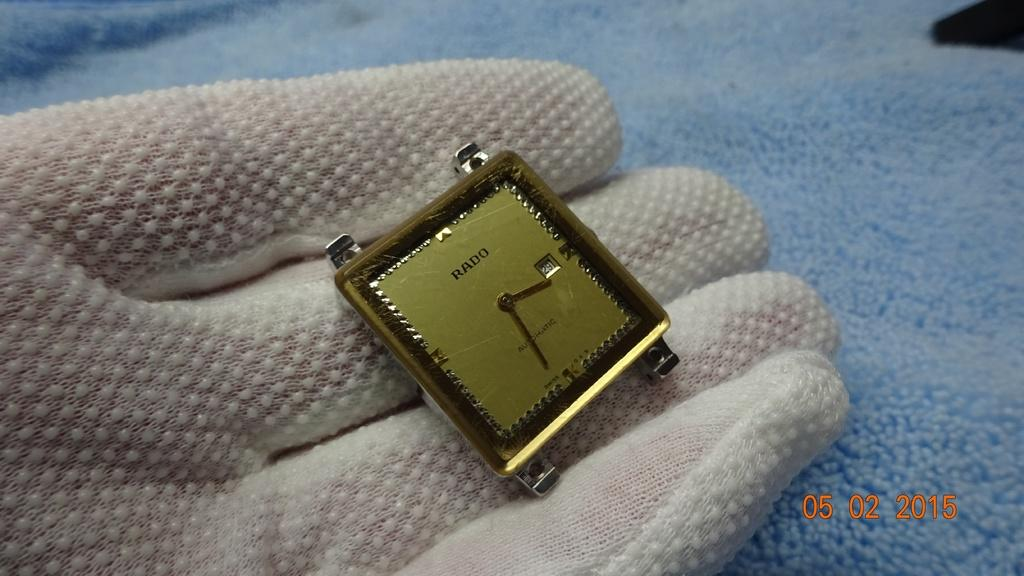<image>
Summarize the visual content of the image. a watch by rado showing the time of 3 22 